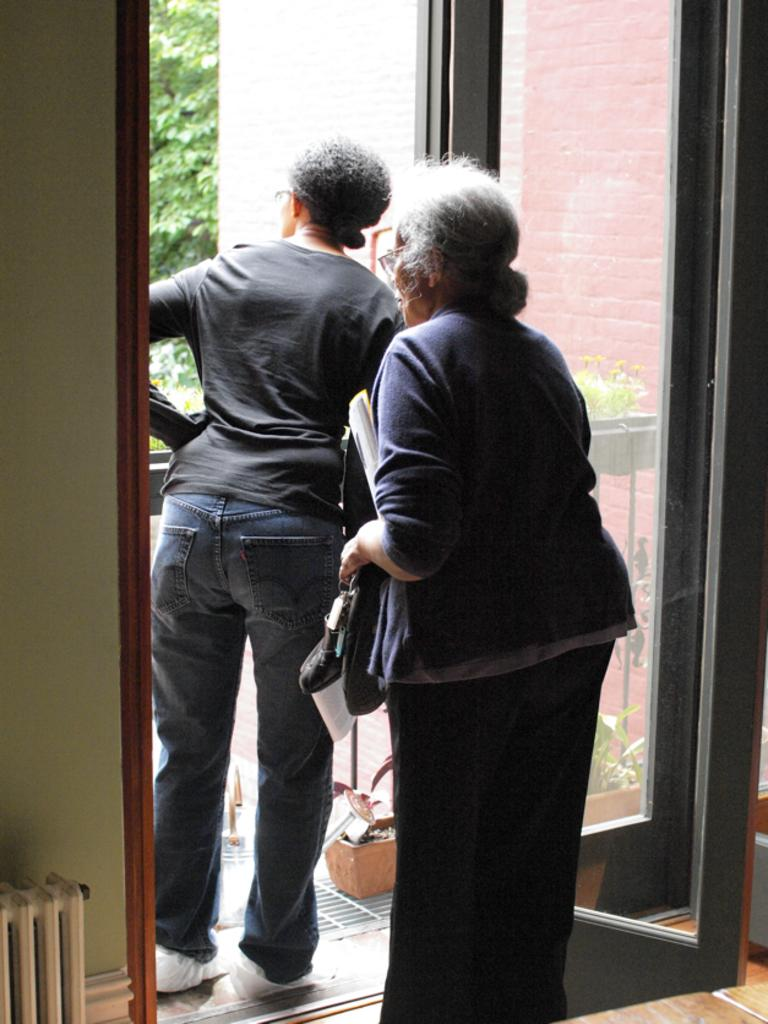What can be seen in the image? There are women standing in the image, along with a building, plants in pots, and a tree in the background. Can you describe the women in the image? The provided facts do not give specific details about the women, so we cannot describe them further. What type of plants are in the pots? The facts do not specify the type of plants in the pots, so we cannot describe them further. How many ladybugs are sitting on the women's shoulders in the image? There is no mention of ladybugs in the provided facts, so we cannot answer this question. What type of debt is being discussed by the women in the image? There is no mention of debt or any conversation in the provided facts, so we cannot answer this question. 